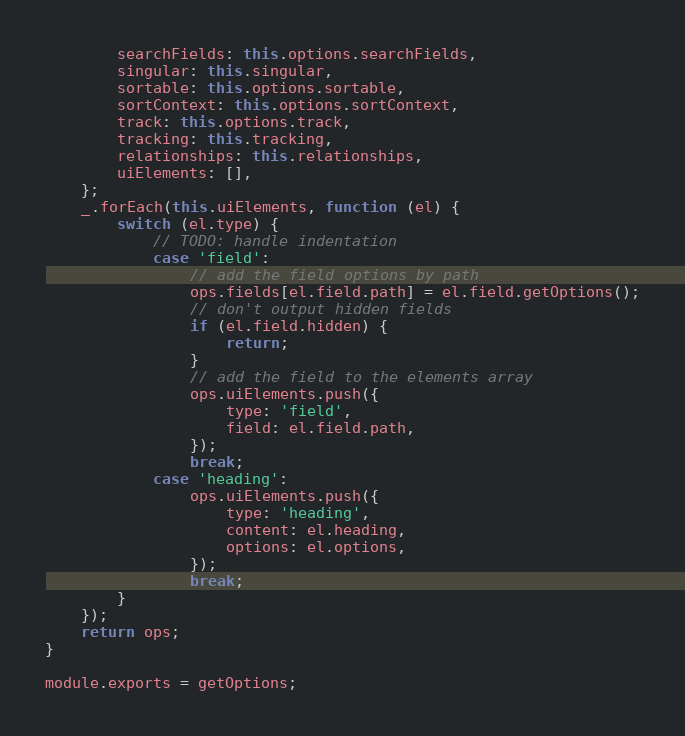<code> <loc_0><loc_0><loc_500><loc_500><_JavaScript_>		searchFields: this.options.searchFields,
		singular: this.singular,
		sortable: this.options.sortable,
		sortContext: this.options.sortContext,
		track: this.options.track,
		tracking: this.tracking,
		relationships: this.relationships,
		uiElements: [],
	};
	_.forEach(this.uiElements, function (el) {
		switch (el.type) {
			// TODO: handle indentation
			case 'field':
				// add the field options by path
				ops.fields[el.field.path] = el.field.getOptions();
				// don't output hidden fields
				if (el.field.hidden) {
					return;
				}
				// add the field to the elements array
				ops.uiElements.push({
					type: 'field',
					field: el.field.path,
				});
				break;
			case 'heading':
				ops.uiElements.push({
					type: 'heading',
					content: el.heading,
					options: el.options,
				});
				break;
		}
	});
	return ops;
}

module.exports = getOptions;
</code> 